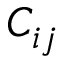Convert formula to latex. <formula><loc_0><loc_0><loc_500><loc_500>C _ { i j }</formula> 